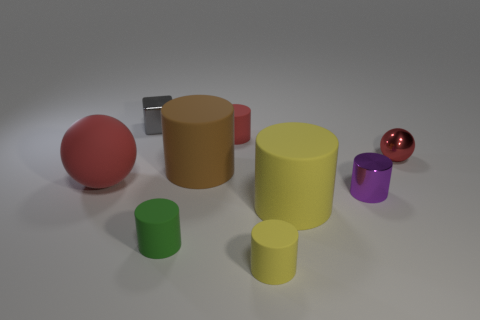Subtract all small purple metallic cylinders. How many cylinders are left? 5 Subtract 2 balls. How many balls are left? 0 Subtract all red cylinders. How many cylinders are left? 5 Subtract all blocks. How many objects are left? 8 Subtract all gray cylinders. How many purple cubes are left? 0 Subtract all small spheres. Subtract all purple cylinders. How many objects are left? 7 Add 2 cubes. How many cubes are left? 3 Add 5 large red objects. How many large red objects exist? 6 Subtract 0 gray balls. How many objects are left? 9 Subtract all blue cylinders. Subtract all blue balls. How many cylinders are left? 6 